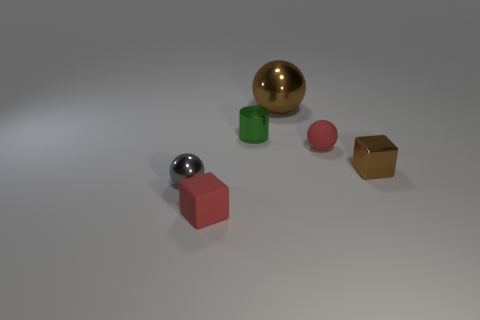Can you guess the size of the objects relative to each other? Relative to each other, the gold-colored cuboid and the red block are similar in size, possibly small handheld objects. The pink sphere and green cylinder are smaller, akin to trinkets or large marbles, while the metallic sphere is the largest of the objects, perhaps resembling something the size of a baseball or an orange. 